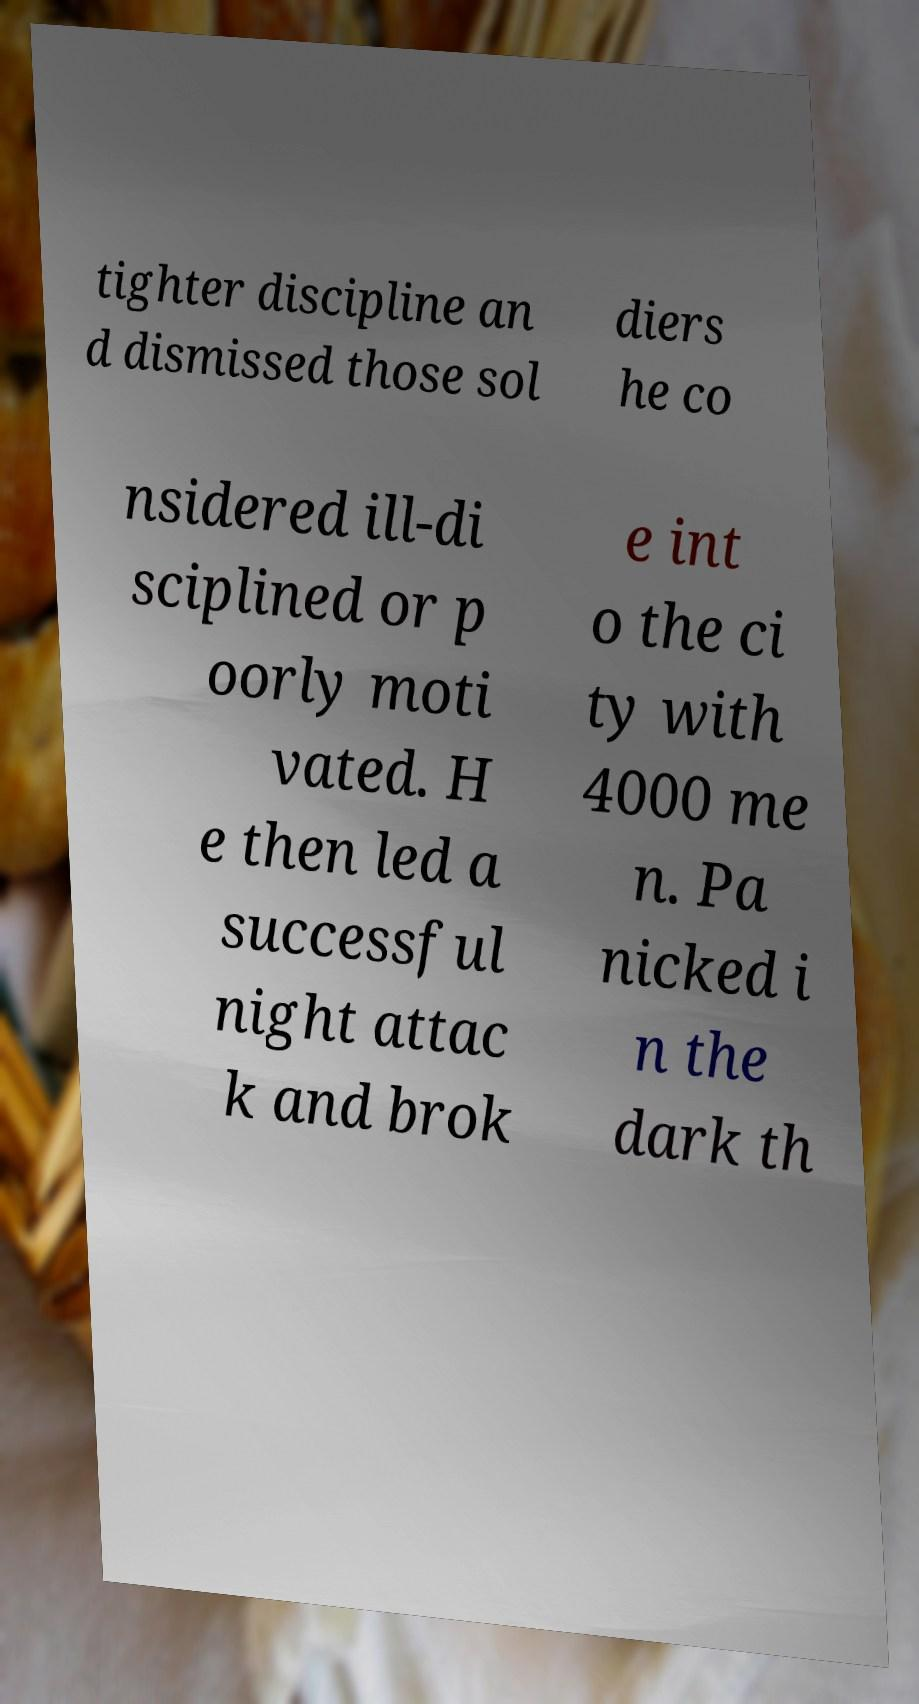Could you extract and type out the text from this image? tighter discipline an d dismissed those sol diers he co nsidered ill-di sciplined or p oorly moti vated. H e then led a successful night attac k and brok e int o the ci ty with 4000 me n. Pa nicked i n the dark th 